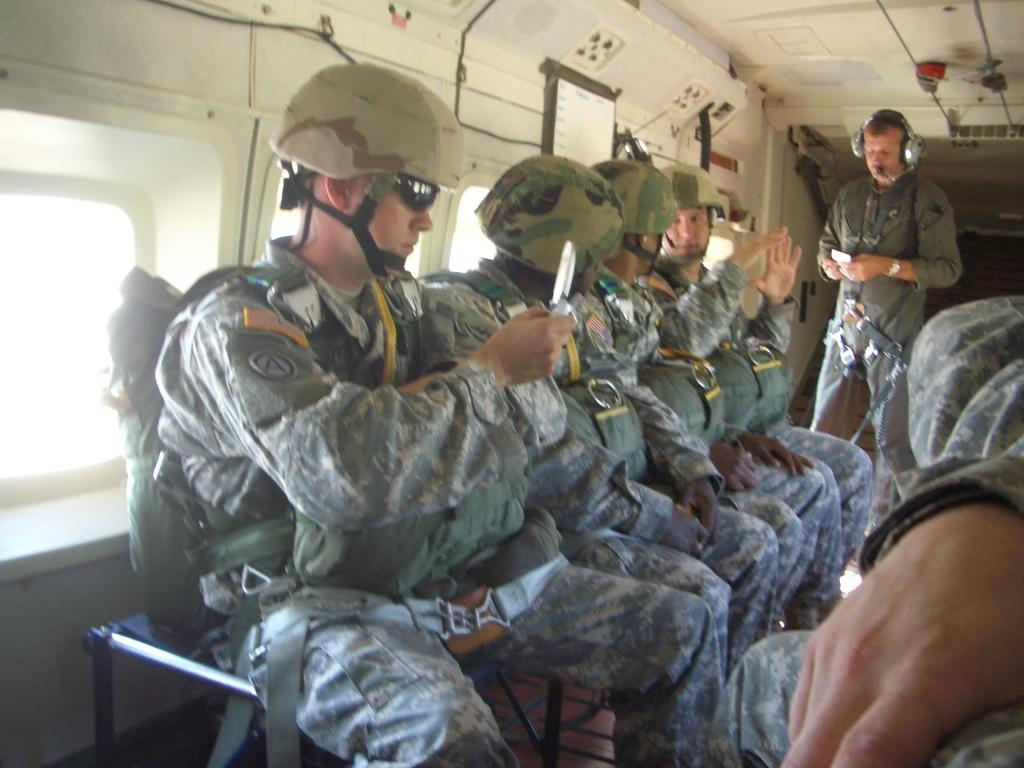How many people are in the image? There are people in the image, but the exact number is not specified. What are the people in the image doing? Some people are sitting, while a man is standing. Can you describe the position of the man on the left side of the image? The man on the left side is standing. What is the man on the left side holding? The man on the left side is holding an object. What is the smell of the sack in the image? There is no sack present in the image, so it is not possible to determine its smell. 